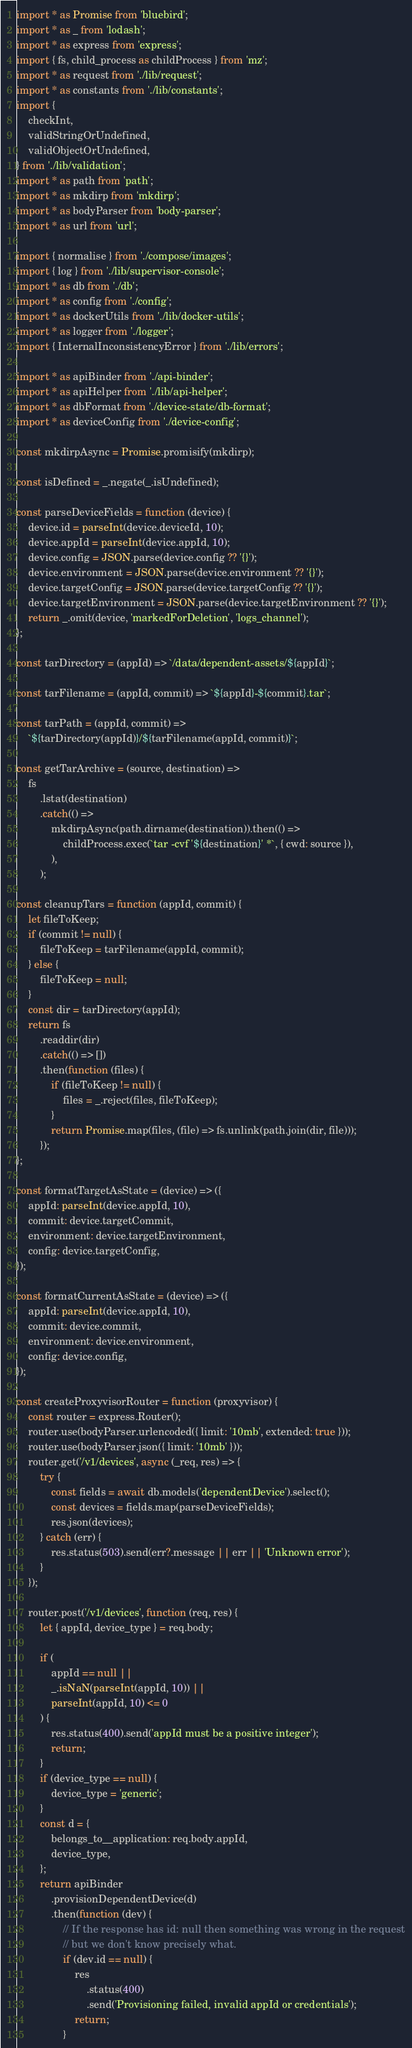<code> <loc_0><loc_0><loc_500><loc_500><_JavaScript_>import * as Promise from 'bluebird';
import * as _ from 'lodash';
import * as express from 'express';
import { fs, child_process as childProcess } from 'mz';
import * as request from './lib/request';
import * as constants from './lib/constants';
import {
	checkInt,
	validStringOrUndefined,
	validObjectOrUndefined,
} from './lib/validation';
import * as path from 'path';
import * as mkdirp from 'mkdirp';
import * as bodyParser from 'body-parser';
import * as url from 'url';

import { normalise } from './compose/images';
import { log } from './lib/supervisor-console';
import * as db from './db';
import * as config from './config';
import * as dockerUtils from './lib/docker-utils';
import * as logger from './logger';
import { InternalInconsistencyError } from './lib/errors';

import * as apiBinder from './api-binder';
import * as apiHelper from './lib/api-helper';
import * as dbFormat from './device-state/db-format';
import * as deviceConfig from './device-config';

const mkdirpAsync = Promise.promisify(mkdirp);

const isDefined = _.negate(_.isUndefined);

const parseDeviceFields = function (device) {
	device.id = parseInt(device.deviceId, 10);
	device.appId = parseInt(device.appId, 10);
	device.config = JSON.parse(device.config ?? '{}');
	device.environment = JSON.parse(device.environment ?? '{}');
	device.targetConfig = JSON.parse(device.targetConfig ?? '{}');
	device.targetEnvironment = JSON.parse(device.targetEnvironment ?? '{}');
	return _.omit(device, 'markedForDeletion', 'logs_channel');
};

const tarDirectory = (appId) => `/data/dependent-assets/${appId}`;

const tarFilename = (appId, commit) => `${appId}-${commit}.tar`;

const tarPath = (appId, commit) =>
	`${tarDirectory(appId)}/${tarFilename(appId, commit)}`;

const getTarArchive = (source, destination) =>
	fs
		.lstat(destination)
		.catch(() =>
			mkdirpAsync(path.dirname(destination)).then(() =>
				childProcess.exec(`tar -cvf '${destination}' *`, { cwd: source }),
			),
		);

const cleanupTars = function (appId, commit) {
	let fileToKeep;
	if (commit != null) {
		fileToKeep = tarFilename(appId, commit);
	} else {
		fileToKeep = null;
	}
	const dir = tarDirectory(appId);
	return fs
		.readdir(dir)
		.catch(() => [])
		.then(function (files) {
			if (fileToKeep != null) {
				files = _.reject(files, fileToKeep);
			}
			return Promise.map(files, (file) => fs.unlink(path.join(dir, file)));
		});
};

const formatTargetAsState = (device) => ({
	appId: parseInt(device.appId, 10),
	commit: device.targetCommit,
	environment: device.targetEnvironment,
	config: device.targetConfig,
});

const formatCurrentAsState = (device) => ({
	appId: parseInt(device.appId, 10),
	commit: device.commit,
	environment: device.environment,
	config: device.config,
});

const createProxyvisorRouter = function (proxyvisor) {
	const router = express.Router();
	router.use(bodyParser.urlencoded({ limit: '10mb', extended: true }));
	router.use(bodyParser.json({ limit: '10mb' }));
	router.get('/v1/devices', async (_req, res) => {
		try {
			const fields = await db.models('dependentDevice').select();
			const devices = fields.map(parseDeviceFields);
			res.json(devices);
		} catch (err) {
			res.status(503).send(err?.message || err || 'Unknown error');
		}
	});

	router.post('/v1/devices', function (req, res) {
		let { appId, device_type } = req.body;

		if (
			appId == null ||
			_.isNaN(parseInt(appId, 10)) ||
			parseInt(appId, 10) <= 0
		) {
			res.status(400).send('appId must be a positive integer');
			return;
		}
		if (device_type == null) {
			device_type = 'generic';
		}
		const d = {
			belongs_to__application: req.body.appId,
			device_type,
		};
		return apiBinder
			.provisionDependentDevice(d)
			.then(function (dev) {
				// If the response has id: null then something was wrong in the request
				// but we don't know precisely what.
				if (dev.id == null) {
					res
						.status(400)
						.send('Provisioning failed, invalid appId or credentials');
					return;
				}</code> 